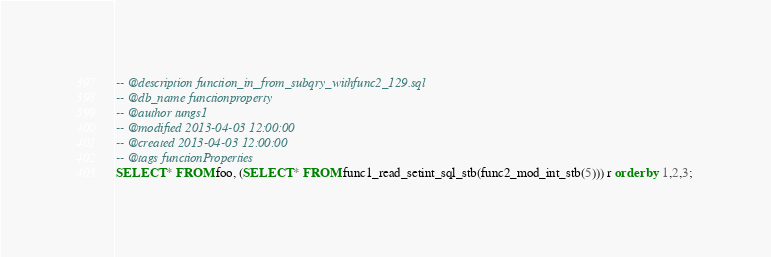Convert code to text. <code><loc_0><loc_0><loc_500><loc_500><_SQL_>-- @description function_in_from_subqry_withfunc2_129.sql
-- @db_name functionproperty
-- @author tungs1
-- @modified 2013-04-03 12:00:00
-- @created 2013-04-03 12:00:00
-- @tags functionProperties 
SELECT * FROM foo, (SELECT * FROM func1_read_setint_sql_stb(func2_mod_int_stb(5))) r order by 1,2,3; 
</code> 